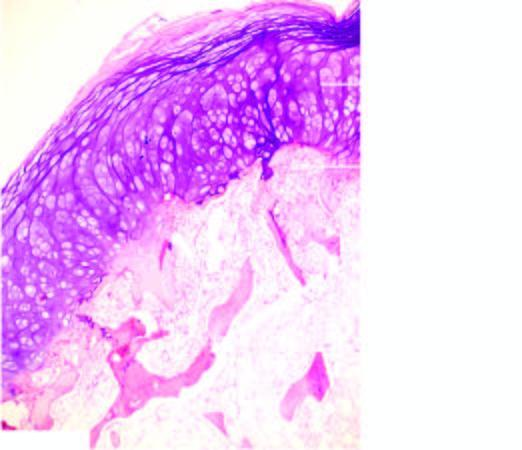does the overlying cap show mature cartilage cells covering the underlying mature lamellar bone containing marrow spaces?
Answer the question using a single word or phrase. Yes 